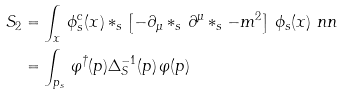<formula> <loc_0><loc_0><loc_500><loc_500>S _ { 2 } & = \int _ { x } \, \phi ^ { c } _ { s } ( x ) * _ { s } \left [ - \partial _ { \mu } * _ { s } \, \partial ^ { \mu } * _ { s } - m ^ { 2 } \right ] \, \phi _ { s } ( x ) \ n n \\ & = \int _ { p _ { s } } \, \varphi ^ { \dagger } ( p ) \Delta _ { S } ^ { - 1 } ( p ) \, \varphi ( p )</formula> 